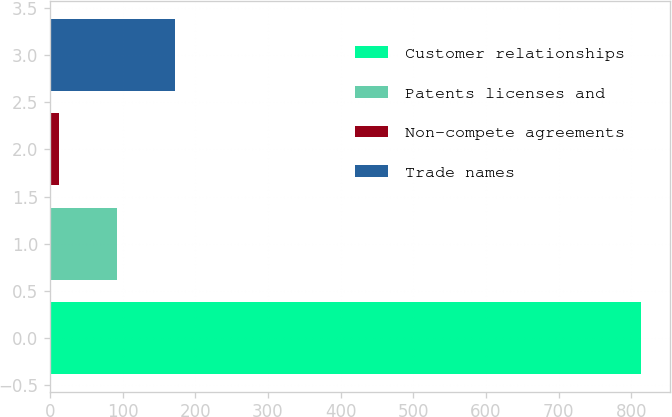Convert chart to OTSL. <chart><loc_0><loc_0><loc_500><loc_500><bar_chart><fcel>Customer relationships<fcel>Patents licenses and<fcel>Non-compete agreements<fcel>Trade names<nl><fcel>812.8<fcel>92.71<fcel>12.7<fcel>172.72<nl></chart> 